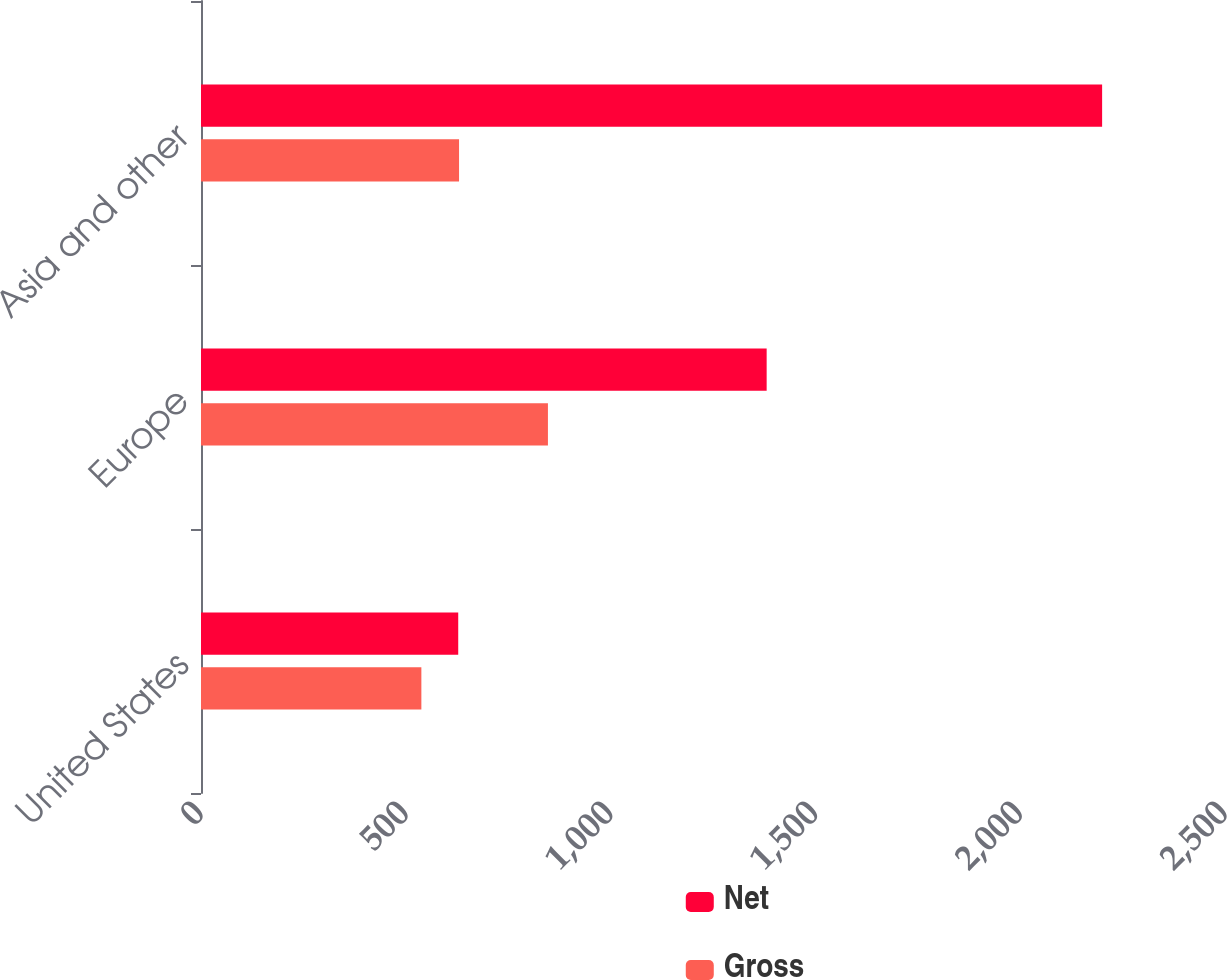Convert chart to OTSL. <chart><loc_0><loc_0><loc_500><loc_500><stacked_bar_chart><ecel><fcel>United States<fcel>Europe<fcel>Asia and other<nl><fcel>Net<fcel>628<fcel>1381<fcel>2200<nl><fcel>Gross<fcel>538<fcel>847<fcel>630<nl></chart> 